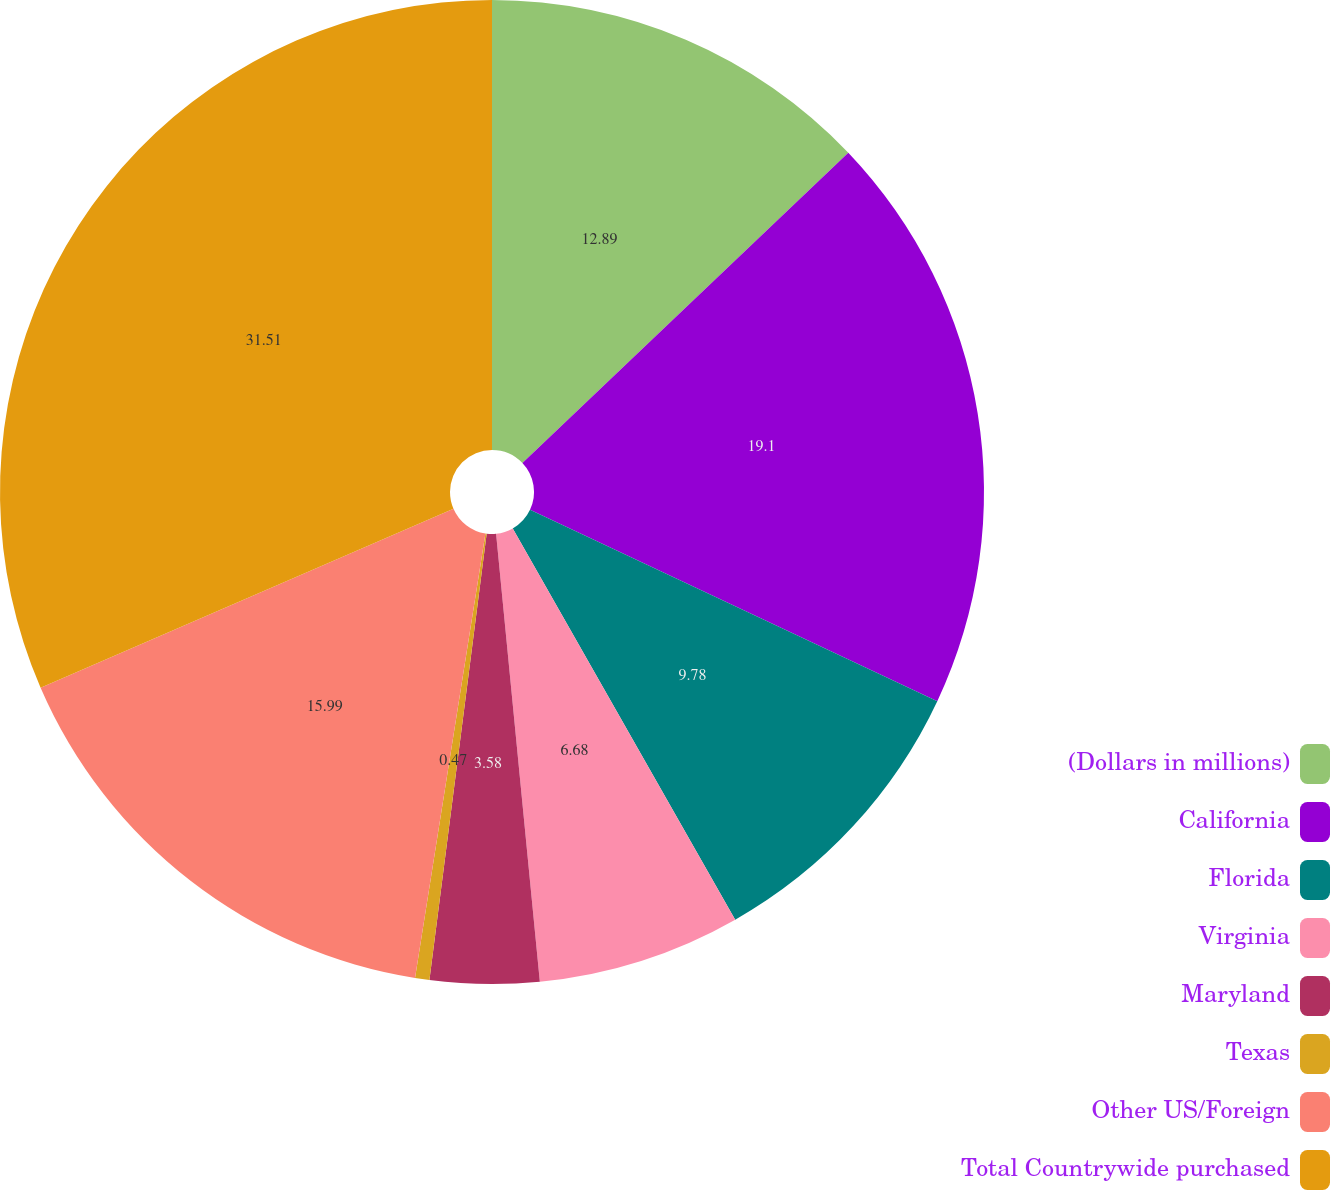<chart> <loc_0><loc_0><loc_500><loc_500><pie_chart><fcel>(Dollars in millions)<fcel>California<fcel>Florida<fcel>Virginia<fcel>Maryland<fcel>Texas<fcel>Other US/Foreign<fcel>Total Countrywide purchased<nl><fcel>12.89%<fcel>19.1%<fcel>9.78%<fcel>6.68%<fcel>3.58%<fcel>0.47%<fcel>15.99%<fcel>31.51%<nl></chart> 